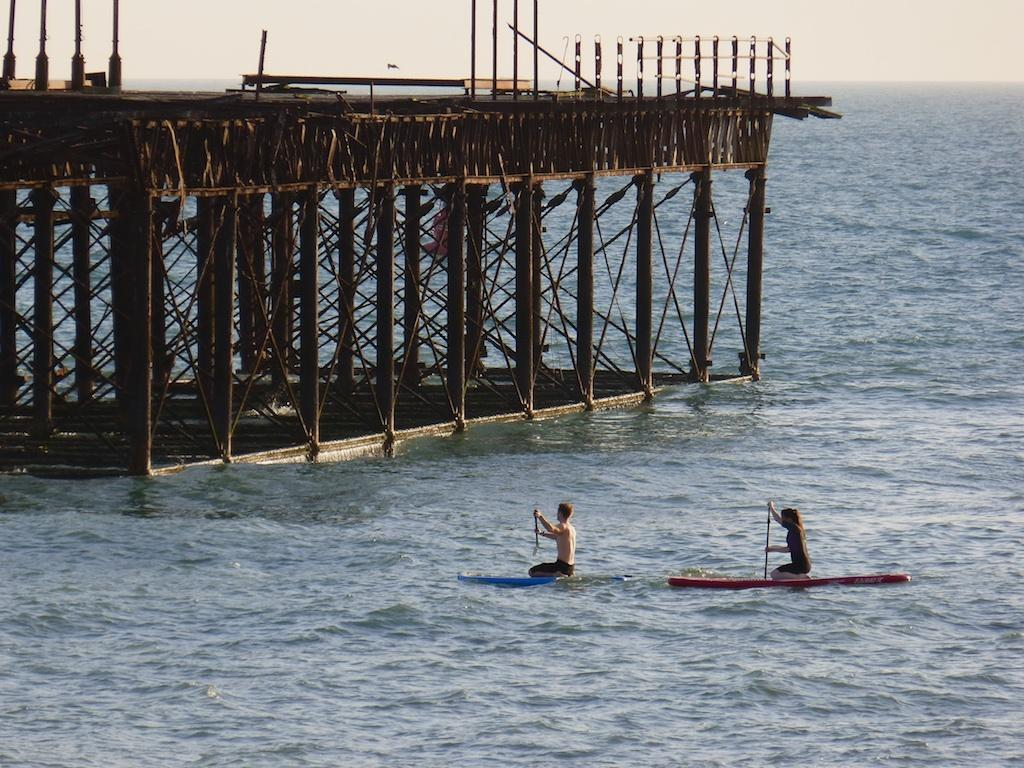What type of structure is located on the left side of the image? There is a trestle bridge on the left side of the image. What natural feature can be seen on the right side of the image? There is the sea visible on the right side of the image. What are the two people in the image doing? The two people in the image are paddling. How many bulbs are hanging from the trestle bridge in the image? There are no bulbs present on the trestle bridge in the image. What type of pleasure can be seen being experienced by the people paddling in the image? The image does not provide information about the emotions or pleasure experienced by the people paddling. 